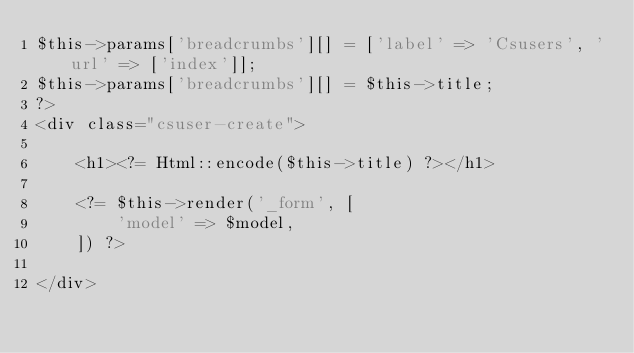<code> <loc_0><loc_0><loc_500><loc_500><_PHP_>$this->params['breadcrumbs'][] = ['label' => 'Csusers', 'url' => ['index']];
$this->params['breadcrumbs'][] = $this->title;
?>
<div class="csuser-create">

    <h1><?= Html::encode($this->title) ?></h1>

    <?= $this->render('_form', [
        'model' => $model,
    ]) ?>

</div>
</code> 